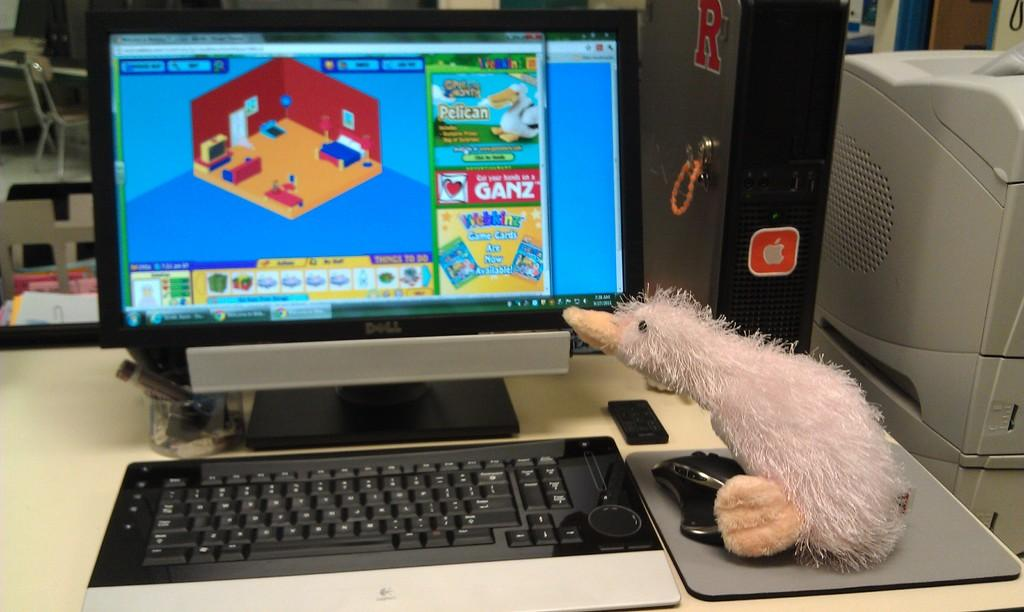Provide a one-sentence caption for the provided image. A stuffed duck examines a computer monitor advertising Webkinz game cards. 